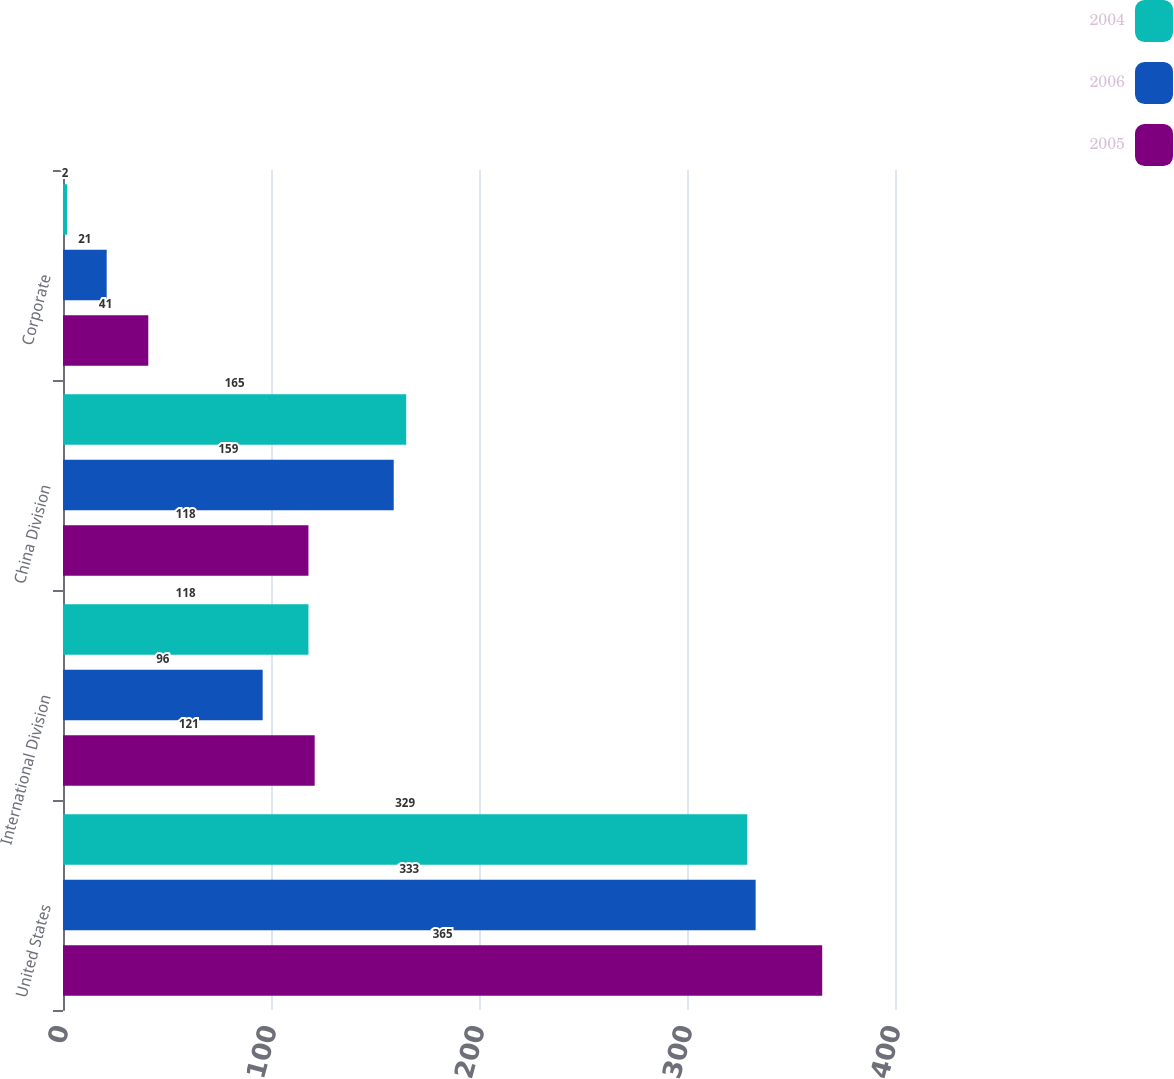Convert chart to OTSL. <chart><loc_0><loc_0><loc_500><loc_500><stacked_bar_chart><ecel><fcel>United States<fcel>International Division<fcel>China Division<fcel>Corporate<nl><fcel>2004<fcel>329<fcel>118<fcel>165<fcel>2<nl><fcel>2006<fcel>333<fcel>96<fcel>159<fcel>21<nl><fcel>2005<fcel>365<fcel>121<fcel>118<fcel>41<nl></chart> 